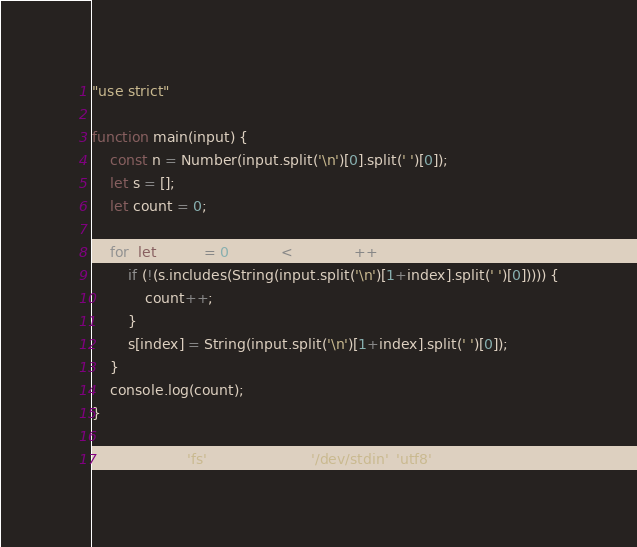Convert code to text. <code><loc_0><loc_0><loc_500><loc_500><_JavaScript_>"use strict"
 
function main(input) {
    const n = Number(input.split('\n')[0].split(' ')[0]);
    let s = [];
    let count = 0;
 
    for (let index = 0; index < n; index++) {
        if (!(s.includes(String(input.split('\n')[1+index].split(' ')[0])))) {
            count++;
        }
        s[index] = String(input.split('\n')[1+index].split(' ')[0]);
    }
    console.log(count);
}

main(require('fs').readFileSync('/dev/stdin', 'utf8'));</code> 